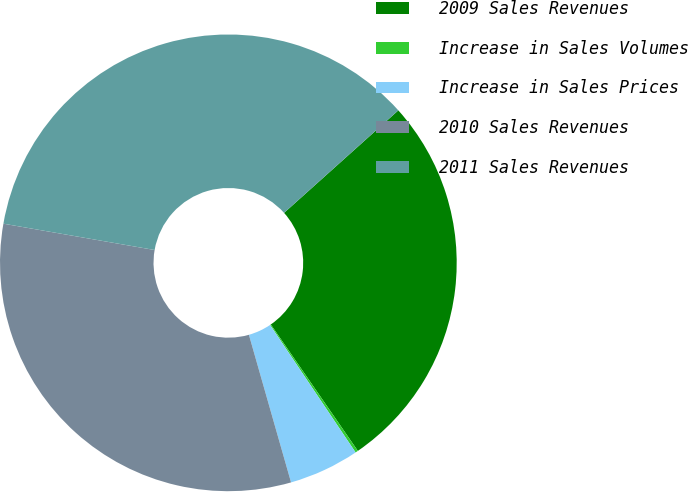<chart> <loc_0><loc_0><loc_500><loc_500><pie_chart><fcel>2009 Sales Revenues<fcel>Increase in Sales Volumes<fcel>Increase in Sales Prices<fcel>2010 Sales Revenues<fcel>2011 Sales Revenues<nl><fcel>27.04%<fcel>0.19%<fcel>4.98%<fcel>32.17%<fcel>35.62%<nl></chart> 